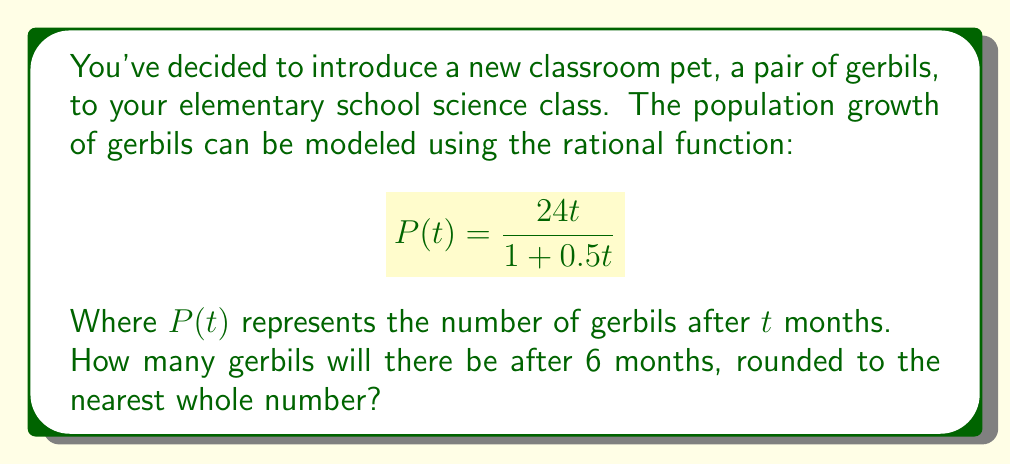Could you help me with this problem? Let's approach this step-by-step:

1) We are given the rational function for gerbil population growth:
   $$P(t) = \frac{24t}{1 + 0.5t}$$

2) We need to find $P(6)$, as we want to know the population after 6 months.

3) Let's substitute $t = 6$ into the function:
   $$P(6) = \frac{24(6)}{1 + 0.5(6)}$$

4) Simplify the numerator and denominator:
   $$P(6) = \frac{144}{1 + 3} = \frac{144}{4}$$

5) Divide:
   $$P(6) = 36$$

6) The question asks for the answer rounded to the nearest whole number, but 36 is already a whole number, so no rounding is necessary.

Thus, after 6 months, there will be 36 gerbils in the classroom.
Answer: 36 gerbils 